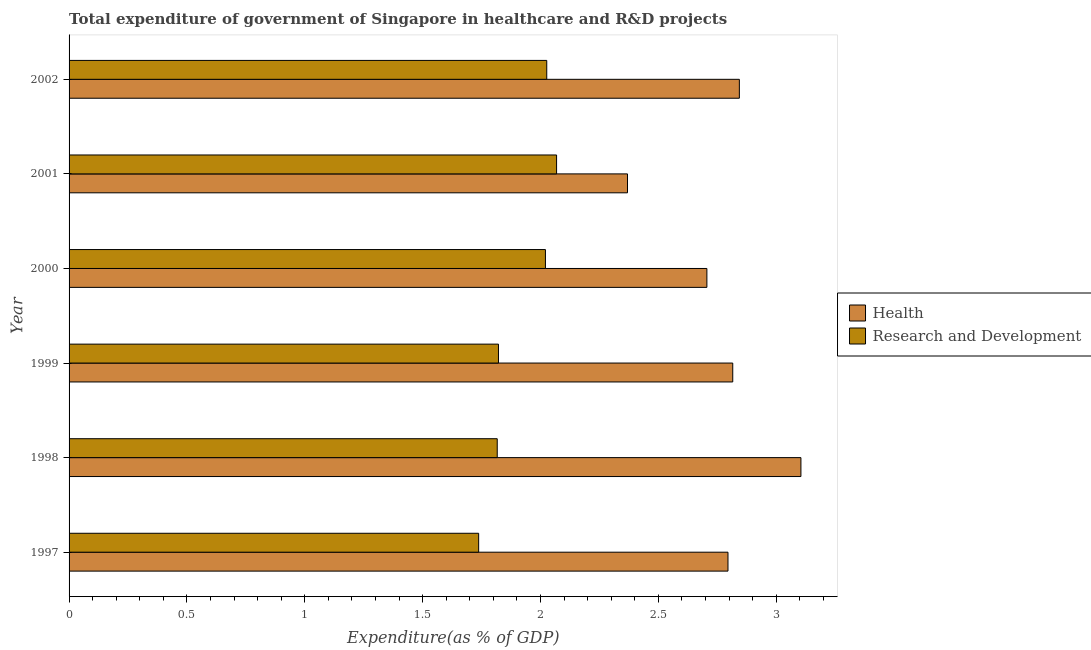How many different coloured bars are there?
Your response must be concise. 2. How many groups of bars are there?
Provide a succinct answer. 6. How many bars are there on the 1st tick from the bottom?
Give a very brief answer. 2. What is the label of the 4th group of bars from the top?
Your answer should be compact. 1999. What is the expenditure in healthcare in 2000?
Keep it short and to the point. 2.71. Across all years, what is the maximum expenditure in r&d?
Keep it short and to the point. 2.07. Across all years, what is the minimum expenditure in healthcare?
Your answer should be compact. 2.37. In which year was the expenditure in r&d maximum?
Ensure brevity in your answer.  2001. What is the total expenditure in healthcare in the graph?
Ensure brevity in your answer.  16.63. What is the difference between the expenditure in r&d in 2001 and that in 2002?
Your answer should be very brief. 0.04. What is the difference between the expenditure in healthcare in 2000 and the expenditure in r&d in 1997?
Ensure brevity in your answer.  0.97. What is the average expenditure in r&d per year?
Provide a short and direct response. 1.92. In the year 1999, what is the difference between the expenditure in healthcare and expenditure in r&d?
Offer a terse response. 0.99. What is the ratio of the expenditure in healthcare in 1997 to that in 1998?
Offer a very short reply. 0.9. Is the difference between the expenditure in r&d in 1999 and 2002 greater than the difference between the expenditure in healthcare in 1999 and 2002?
Ensure brevity in your answer.  No. What is the difference between the highest and the second highest expenditure in r&d?
Ensure brevity in your answer.  0.04. What is the difference between the highest and the lowest expenditure in healthcare?
Offer a terse response. 0.74. In how many years, is the expenditure in healthcare greater than the average expenditure in healthcare taken over all years?
Provide a short and direct response. 4. Is the sum of the expenditure in healthcare in 1997 and 2002 greater than the maximum expenditure in r&d across all years?
Offer a terse response. Yes. What does the 2nd bar from the top in 1998 represents?
Offer a very short reply. Health. What does the 2nd bar from the bottom in 2000 represents?
Ensure brevity in your answer.  Research and Development. How many bars are there?
Keep it short and to the point. 12. Are all the bars in the graph horizontal?
Your response must be concise. Yes. How many years are there in the graph?
Offer a very short reply. 6. What is the difference between two consecutive major ticks on the X-axis?
Provide a short and direct response. 0.5. Are the values on the major ticks of X-axis written in scientific E-notation?
Give a very brief answer. No. Does the graph contain grids?
Ensure brevity in your answer.  No. How many legend labels are there?
Make the answer very short. 2. What is the title of the graph?
Provide a succinct answer. Total expenditure of government of Singapore in healthcare and R&D projects. Does "Travel services" appear as one of the legend labels in the graph?
Your answer should be compact. No. What is the label or title of the X-axis?
Provide a succinct answer. Expenditure(as % of GDP). What is the Expenditure(as % of GDP) in Health in 1997?
Make the answer very short. 2.8. What is the Expenditure(as % of GDP) in Research and Development in 1997?
Your answer should be compact. 1.74. What is the Expenditure(as % of GDP) of Health in 1998?
Make the answer very short. 3.1. What is the Expenditure(as % of GDP) of Research and Development in 1998?
Your response must be concise. 1.82. What is the Expenditure(as % of GDP) of Health in 1999?
Provide a short and direct response. 2.82. What is the Expenditure(as % of GDP) in Research and Development in 1999?
Your answer should be compact. 1.82. What is the Expenditure(as % of GDP) in Health in 2000?
Your answer should be very brief. 2.71. What is the Expenditure(as % of GDP) of Research and Development in 2000?
Your answer should be very brief. 2.02. What is the Expenditure(as % of GDP) in Health in 2001?
Your answer should be very brief. 2.37. What is the Expenditure(as % of GDP) of Research and Development in 2001?
Make the answer very short. 2.07. What is the Expenditure(as % of GDP) in Health in 2002?
Offer a terse response. 2.84. What is the Expenditure(as % of GDP) in Research and Development in 2002?
Provide a succinct answer. 2.03. Across all years, what is the maximum Expenditure(as % of GDP) of Health?
Make the answer very short. 3.1. Across all years, what is the maximum Expenditure(as % of GDP) of Research and Development?
Your response must be concise. 2.07. Across all years, what is the minimum Expenditure(as % of GDP) in Health?
Your answer should be very brief. 2.37. Across all years, what is the minimum Expenditure(as % of GDP) in Research and Development?
Provide a succinct answer. 1.74. What is the total Expenditure(as % of GDP) of Health in the graph?
Provide a succinct answer. 16.63. What is the total Expenditure(as % of GDP) of Research and Development in the graph?
Keep it short and to the point. 11.49. What is the difference between the Expenditure(as % of GDP) of Health in 1997 and that in 1998?
Give a very brief answer. -0.31. What is the difference between the Expenditure(as % of GDP) of Research and Development in 1997 and that in 1998?
Provide a succinct answer. -0.08. What is the difference between the Expenditure(as % of GDP) in Health in 1997 and that in 1999?
Offer a very short reply. -0.02. What is the difference between the Expenditure(as % of GDP) in Research and Development in 1997 and that in 1999?
Provide a succinct answer. -0.08. What is the difference between the Expenditure(as % of GDP) in Health in 1997 and that in 2000?
Your answer should be very brief. 0.09. What is the difference between the Expenditure(as % of GDP) of Research and Development in 1997 and that in 2000?
Provide a short and direct response. -0.28. What is the difference between the Expenditure(as % of GDP) of Health in 1997 and that in 2001?
Provide a short and direct response. 0.43. What is the difference between the Expenditure(as % of GDP) of Research and Development in 1997 and that in 2001?
Ensure brevity in your answer.  -0.33. What is the difference between the Expenditure(as % of GDP) in Health in 1997 and that in 2002?
Offer a very short reply. -0.05. What is the difference between the Expenditure(as % of GDP) in Research and Development in 1997 and that in 2002?
Make the answer very short. -0.29. What is the difference between the Expenditure(as % of GDP) of Health in 1998 and that in 1999?
Provide a short and direct response. 0.29. What is the difference between the Expenditure(as % of GDP) of Research and Development in 1998 and that in 1999?
Your response must be concise. -0.01. What is the difference between the Expenditure(as % of GDP) of Health in 1998 and that in 2000?
Provide a short and direct response. 0.4. What is the difference between the Expenditure(as % of GDP) in Research and Development in 1998 and that in 2000?
Give a very brief answer. -0.2. What is the difference between the Expenditure(as % of GDP) of Health in 1998 and that in 2001?
Offer a terse response. 0.74. What is the difference between the Expenditure(as % of GDP) in Research and Development in 1998 and that in 2001?
Make the answer very short. -0.25. What is the difference between the Expenditure(as % of GDP) of Health in 1998 and that in 2002?
Provide a short and direct response. 0.26. What is the difference between the Expenditure(as % of GDP) of Research and Development in 1998 and that in 2002?
Your answer should be very brief. -0.21. What is the difference between the Expenditure(as % of GDP) in Health in 1999 and that in 2000?
Ensure brevity in your answer.  0.11. What is the difference between the Expenditure(as % of GDP) of Research and Development in 1999 and that in 2000?
Ensure brevity in your answer.  -0.2. What is the difference between the Expenditure(as % of GDP) in Health in 1999 and that in 2001?
Your answer should be compact. 0.45. What is the difference between the Expenditure(as % of GDP) in Research and Development in 1999 and that in 2001?
Give a very brief answer. -0.25. What is the difference between the Expenditure(as % of GDP) in Health in 1999 and that in 2002?
Offer a terse response. -0.03. What is the difference between the Expenditure(as % of GDP) of Research and Development in 1999 and that in 2002?
Keep it short and to the point. -0.2. What is the difference between the Expenditure(as % of GDP) in Health in 2000 and that in 2001?
Provide a short and direct response. 0.34. What is the difference between the Expenditure(as % of GDP) of Research and Development in 2000 and that in 2001?
Make the answer very short. -0.05. What is the difference between the Expenditure(as % of GDP) of Health in 2000 and that in 2002?
Provide a short and direct response. -0.14. What is the difference between the Expenditure(as % of GDP) in Research and Development in 2000 and that in 2002?
Provide a short and direct response. -0.01. What is the difference between the Expenditure(as % of GDP) of Health in 2001 and that in 2002?
Make the answer very short. -0.47. What is the difference between the Expenditure(as % of GDP) of Research and Development in 2001 and that in 2002?
Provide a succinct answer. 0.04. What is the difference between the Expenditure(as % of GDP) of Health in 1997 and the Expenditure(as % of GDP) of Research and Development in 1998?
Your response must be concise. 0.98. What is the difference between the Expenditure(as % of GDP) in Health in 1997 and the Expenditure(as % of GDP) in Research and Development in 1999?
Give a very brief answer. 0.97. What is the difference between the Expenditure(as % of GDP) of Health in 1997 and the Expenditure(as % of GDP) of Research and Development in 2000?
Offer a very short reply. 0.77. What is the difference between the Expenditure(as % of GDP) of Health in 1997 and the Expenditure(as % of GDP) of Research and Development in 2001?
Your answer should be compact. 0.73. What is the difference between the Expenditure(as % of GDP) in Health in 1997 and the Expenditure(as % of GDP) in Research and Development in 2002?
Offer a terse response. 0.77. What is the difference between the Expenditure(as % of GDP) in Health in 1998 and the Expenditure(as % of GDP) in Research and Development in 1999?
Offer a very short reply. 1.28. What is the difference between the Expenditure(as % of GDP) in Health in 1998 and the Expenditure(as % of GDP) in Research and Development in 2000?
Your answer should be very brief. 1.08. What is the difference between the Expenditure(as % of GDP) of Health in 1998 and the Expenditure(as % of GDP) of Research and Development in 2001?
Your answer should be compact. 1.04. What is the difference between the Expenditure(as % of GDP) in Health in 1998 and the Expenditure(as % of GDP) in Research and Development in 2002?
Keep it short and to the point. 1.08. What is the difference between the Expenditure(as % of GDP) in Health in 1999 and the Expenditure(as % of GDP) in Research and Development in 2000?
Make the answer very short. 0.79. What is the difference between the Expenditure(as % of GDP) in Health in 1999 and the Expenditure(as % of GDP) in Research and Development in 2001?
Provide a succinct answer. 0.75. What is the difference between the Expenditure(as % of GDP) of Health in 1999 and the Expenditure(as % of GDP) of Research and Development in 2002?
Your response must be concise. 0.79. What is the difference between the Expenditure(as % of GDP) of Health in 2000 and the Expenditure(as % of GDP) of Research and Development in 2001?
Your answer should be very brief. 0.64. What is the difference between the Expenditure(as % of GDP) in Health in 2000 and the Expenditure(as % of GDP) in Research and Development in 2002?
Your answer should be compact. 0.68. What is the difference between the Expenditure(as % of GDP) of Health in 2001 and the Expenditure(as % of GDP) of Research and Development in 2002?
Ensure brevity in your answer.  0.34. What is the average Expenditure(as % of GDP) in Health per year?
Your response must be concise. 2.77. What is the average Expenditure(as % of GDP) in Research and Development per year?
Provide a short and direct response. 1.92. In the year 1997, what is the difference between the Expenditure(as % of GDP) of Health and Expenditure(as % of GDP) of Research and Development?
Ensure brevity in your answer.  1.06. In the year 1998, what is the difference between the Expenditure(as % of GDP) in Health and Expenditure(as % of GDP) in Research and Development?
Your response must be concise. 1.29. In the year 2000, what is the difference between the Expenditure(as % of GDP) in Health and Expenditure(as % of GDP) in Research and Development?
Your answer should be very brief. 0.69. In the year 2001, what is the difference between the Expenditure(as % of GDP) in Health and Expenditure(as % of GDP) in Research and Development?
Keep it short and to the point. 0.3. In the year 2002, what is the difference between the Expenditure(as % of GDP) in Health and Expenditure(as % of GDP) in Research and Development?
Your answer should be compact. 0.82. What is the ratio of the Expenditure(as % of GDP) of Health in 1997 to that in 1998?
Offer a very short reply. 0.9. What is the ratio of the Expenditure(as % of GDP) in Research and Development in 1997 to that in 1998?
Offer a terse response. 0.96. What is the ratio of the Expenditure(as % of GDP) of Health in 1997 to that in 1999?
Your answer should be very brief. 0.99. What is the ratio of the Expenditure(as % of GDP) of Research and Development in 1997 to that in 1999?
Keep it short and to the point. 0.95. What is the ratio of the Expenditure(as % of GDP) of Health in 1997 to that in 2000?
Ensure brevity in your answer.  1.03. What is the ratio of the Expenditure(as % of GDP) of Research and Development in 1997 to that in 2000?
Give a very brief answer. 0.86. What is the ratio of the Expenditure(as % of GDP) in Health in 1997 to that in 2001?
Your response must be concise. 1.18. What is the ratio of the Expenditure(as % of GDP) of Research and Development in 1997 to that in 2001?
Provide a succinct answer. 0.84. What is the ratio of the Expenditure(as % of GDP) in Research and Development in 1997 to that in 2002?
Keep it short and to the point. 0.86. What is the ratio of the Expenditure(as % of GDP) in Health in 1998 to that in 1999?
Provide a succinct answer. 1.1. What is the ratio of the Expenditure(as % of GDP) in Health in 1998 to that in 2000?
Ensure brevity in your answer.  1.15. What is the ratio of the Expenditure(as % of GDP) of Research and Development in 1998 to that in 2000?
Offer a very short reply. 0.9. What is the ratio of the Expenditure(as % of GDP) in Health in 1998 to that in 2001?
Keep it short and to the point. 1.31. What is the ratio of the Expenditure(as % of GDP) in Research and Development in 1998 to that in 2001?
Make the answer very short. 0.88. What is the ratio of the Expenditure(as % of GDP) of Health in 1998 to that in 2002?
Your answer should be very brief. 1.09. What is the ratio of the Expenditure(as % of GDP) in Research and Development in 1998 to that in 2002?
Your response must be concise. 0.9. What is the ratio of the Expenditure(as % of GDP) in Health in 1999 to that in 2000?
Offer a very short reply. 1.04. What is the ratio of the Expenditure(as % of GDP) of Research and Development in 1999 to that in 2000?
Your answer should be compact. 0.9. What is the ratio of the Expenditure(as % of GDP) of Health in 1999 to that in 2001?
Ensure brevity in your answer.  1.19. What is the ratio of the Expenditure(as % of GDP) of Research and Development in 1999 to that in 2001?
Your answer should be very brief. 0.88. What is the ratio of the Expenditure(as % of GDP) in Health in 1999 to that in 2002?
Your response must be concise. 0.99. What is the ratio of the Expenditure(as % of GDP) of Research and Development in 1999 to that in 2002?
Your response must be concise. 0.9. What is the ratio of the Expenditure(as % of GDP) of Health in 2000 to that in 2001?
Ensure brevity in your answer.  1.14. What is the ratio of the Expenditure(as % of GDP) of Research and Development in 2000 to that in 2001?
Your answer should be compact. 0.98. What is the ratio of the Expenditure(as % of GDP) in Health in 2000 to that in 2002?
Ensure brevity in your answer.  0.95. What is the ratio of the Expenditure(as % of GDP) in Research and Development in 2000 to that in 2002?
Your response must be concise. 1. What is the ratio of the Expenditure(as % of GDP) in Health in 2001 to that in 2002?
Give a very brief answer. 0.83. What is the ratio of the Expenditure(as % of GDP) of Research and Development in 2001 to that in 2002?
Offer a terse response. 1.02. What is the difference between the highest and the second highest Expenditure(as % of GDP) in Health?
Your response must be concise. 0.26. What is the difference between the highest and the second highest Expenditure(as % of GDP) of Research and Development?
Provide a short and direct response. 0.04. What is the difference between the highest and the lowest Expenditure(as % of GDP) of Health?
Your response must be concise. 0.74. What is the difference between the highest and the lowest Expenditure(as % of GDP) of Research and Development?
Keep it short and to the point. 0.33. 